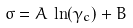Convert formula to latex. <formula><loc_0><loc_0><loc_500><loc_500>\sigma = A \, \ln ( \gamma _ { c } ) + B</formula> 